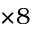Convert formula to latex. <formula><loc_0><loc_0><loc_500><loc_500>\times 8</formula> 